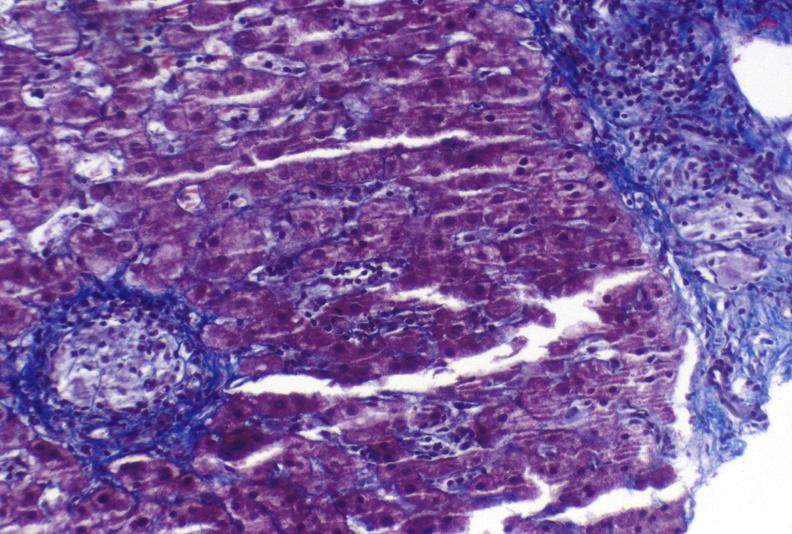s no tissue recognizable as ovary present?
Answer the question using a single word or phrase. No 